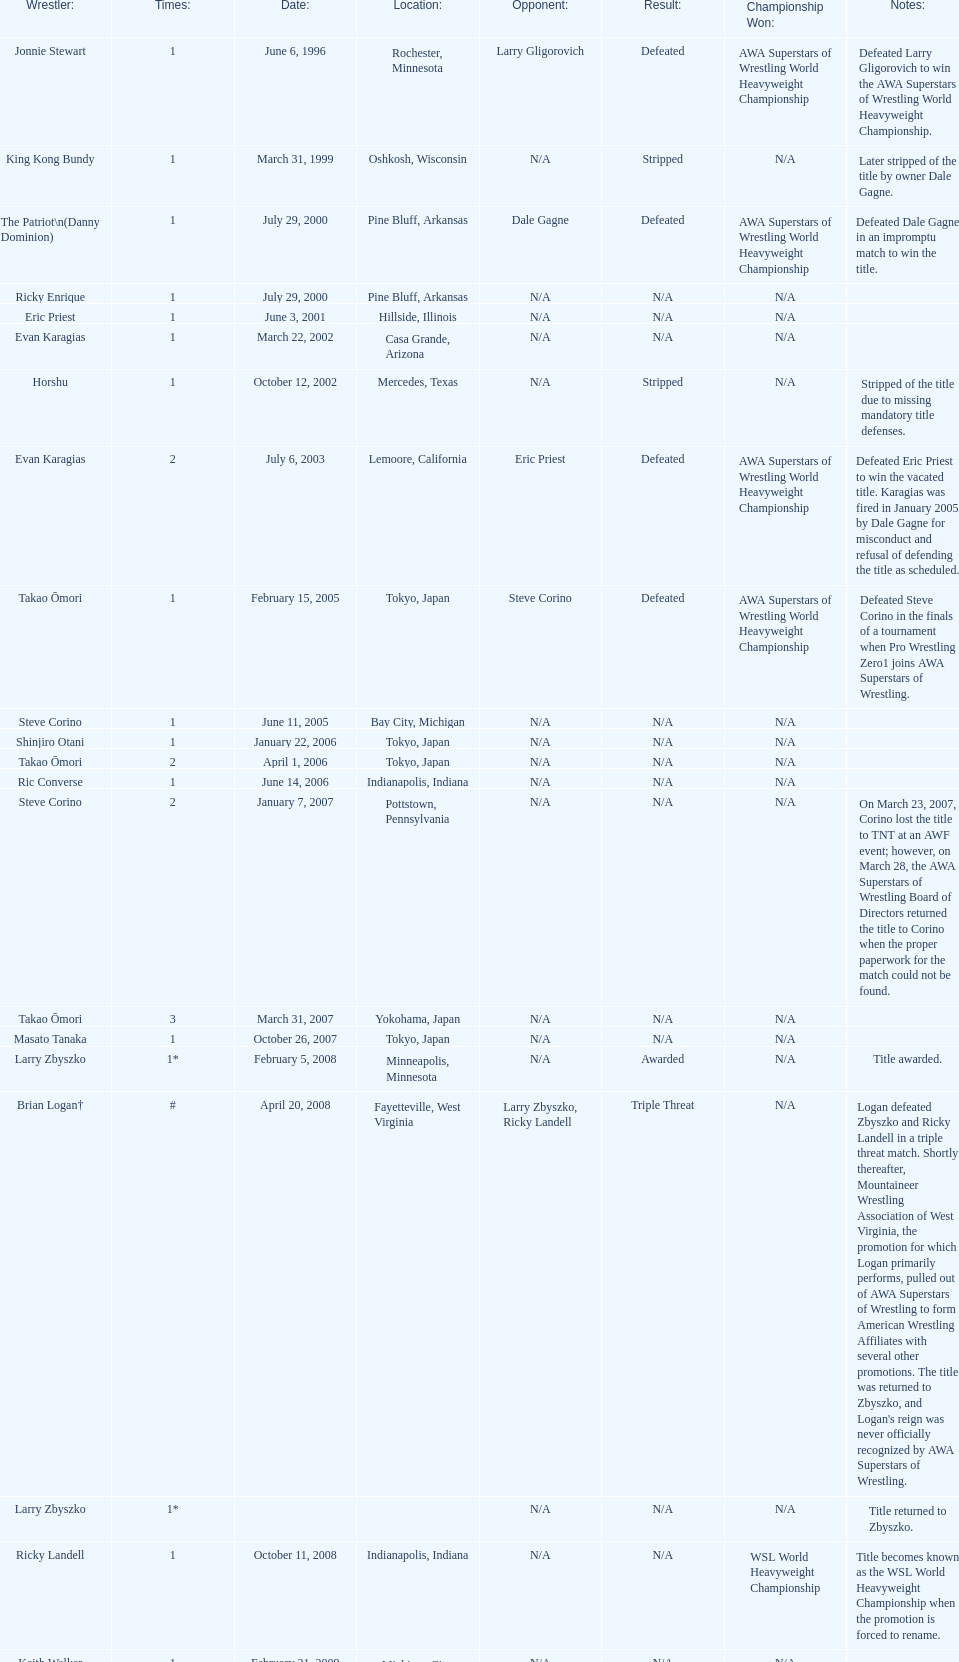When did steve corino win his first wsl title? June 11, 2005. 